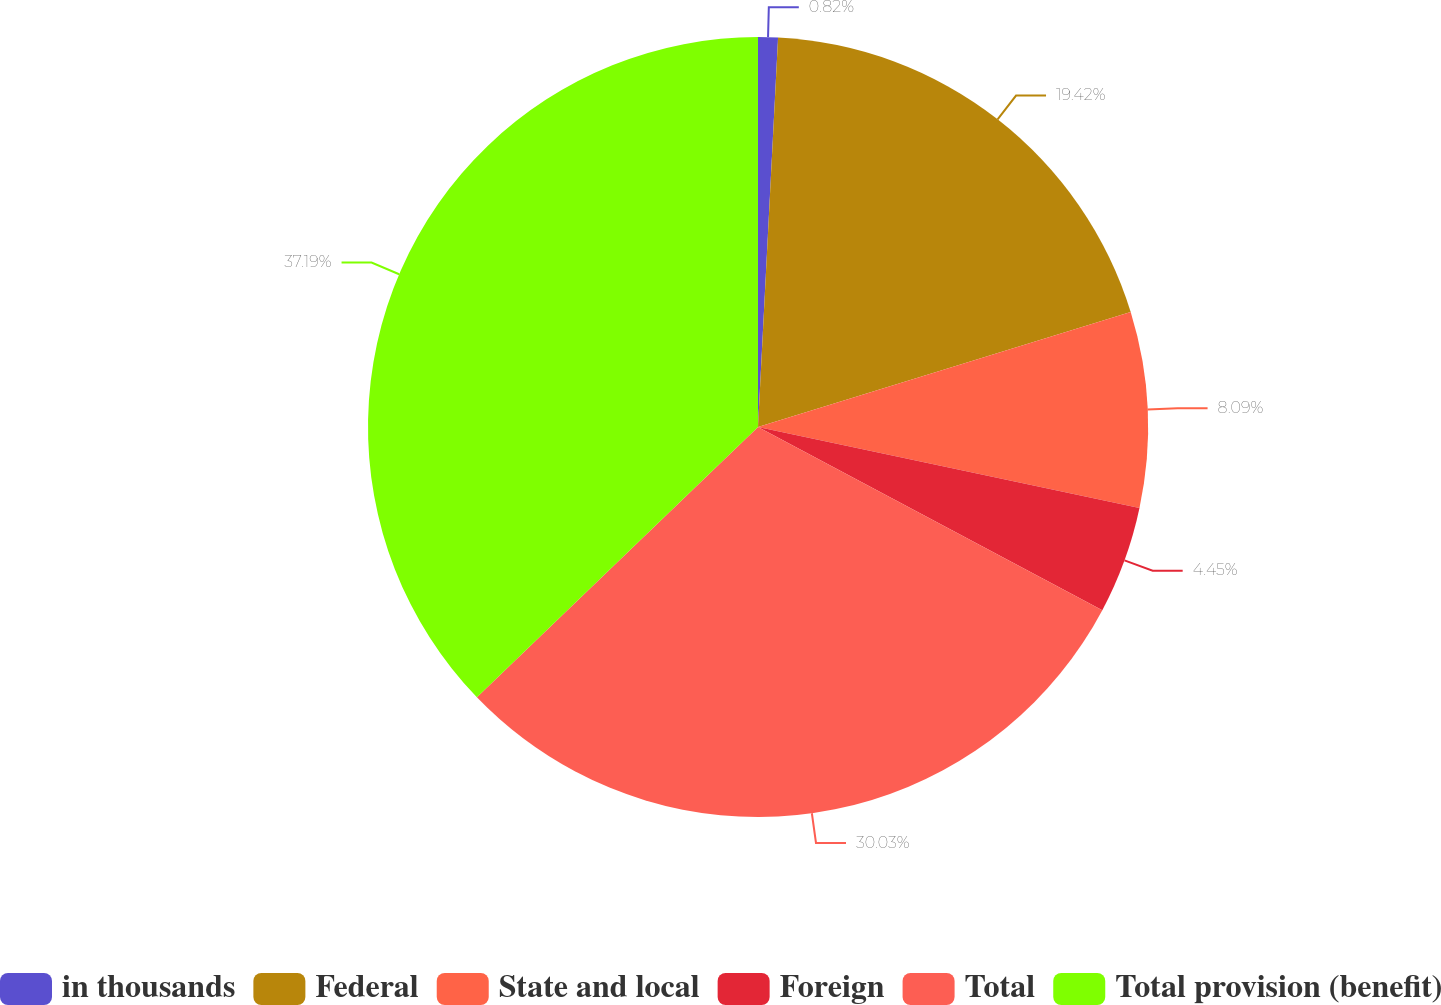<chart> <loc_0><loc_0><loc_500><loc_500><pie_chart><fcel>in thousands<fcel>Federal<fcel>State and local<fcel>Foreign<fcel>Total<fcel>Total provision (benefit)<nl><fcel>0.82%<fcel>19.42%<fcel>8.09%<fcel>4.45%<fcel>30.03%<fcel>37.19%<nl></chart> 